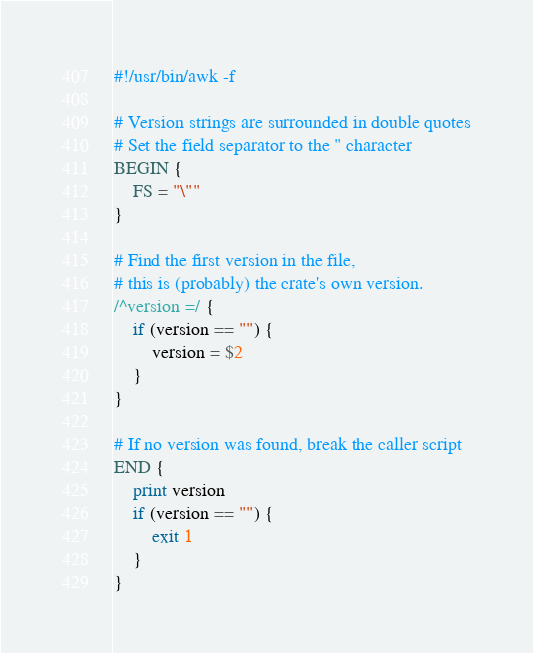<code> <loc_0><loc_0><loc_500><loc_500><_Awk_>#!/usr/bin/awk -f

# Version strings are surrounded in double quotes
# Set the field separator to the " character
BEGIN {
    FS = "\""
}

# Find the first version in the file,
# this is (probably) the crate's own version.
/^version =/ {
    if (version == "") {
        version = $2
    }
}

# If no version was found, break the caller script
END {
    print version
    if (version == "") {
        exit 1
    }
}
</code> 